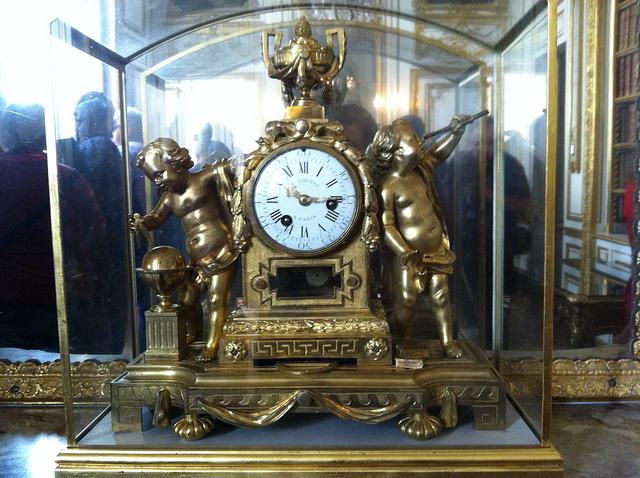What is located behind the clock? Please explain your reasoning. mirror. People's shadows are being reflected in the mirror. 